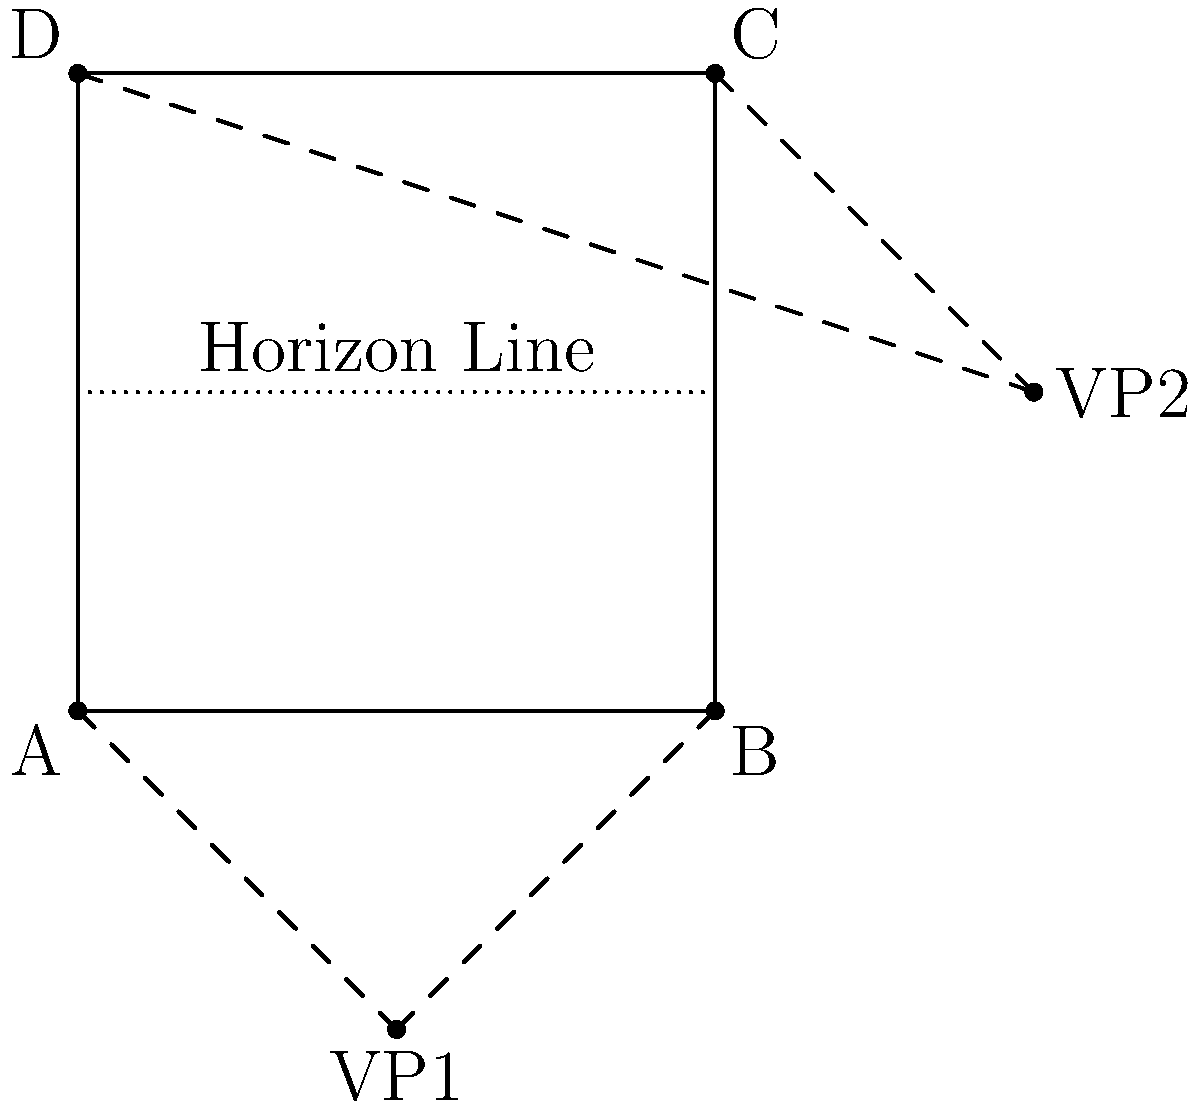In a cityscape sketch, an artist uses two-point perspective to create depth. Given that the vanishing points (VP1 and VP2) are located at coordinates (-50, 50) and (150, 50) respectively, and the front face of a building is represented by a square ABCD with side length 100 units, what is the angle formed between the lines connecting point A to VP1 and VP2? To find the angle formed by the lines connecting point A to VP1 and VP2, we can follow these steps:

1. Identify the coordinates:
   A (0, 0), VP1 (-50, 50), VP2 (150, 50)

2. Calculate the vectors from A to VP1 and VP2:
   $\vec{AV1} = (-50 - 0, 50 - 0) = (-50, 50)$
   $\vec{AV2} = (150 - 0, 50 - 0) = (150, 50)$

3. Use the dot product formula to find the angle:
   $\cos \theta = \frac{\vec{AV1} \cdot \vec{AV2}}{|\vec{AV1}| |\vec{AV2}|}$

4. Calculate the dot product:
   $\vec{AV1} \cdot \vec{AV2} = (-50 \times 150) + (50 \times 50) = -7500 + 2500 = -5000$

5. Calculate the magnitudes:
   $|\vec{AV1}| = \sqrt{(-50)^2 + 50^2} = \sqrt{5000}$
   $|\vec{AV2}| = \sqrt{150^2 + 50^2} = \sqrt{25000}$

6. Substitute into the formula:
   $\cos \theta = \frac{-5000}{\sqrt{5000} \sqrt{25000}} = \frac{-5000}{\sqrt{125000000}} = -\frac{1}{\sqrt{5}}$

7. Take the inverse cosine (arccos) of both sides:
   $\theta = \arccos(-\frac{1}{\sqrt{5}})$

8. Calculate the result:
   $\theta \approx 2.6290$ radians or $150.6375$ degrees
Answer: $\arccos(-\frac{1}{\sqrt{5}})$ radians or approximately 150.64° 